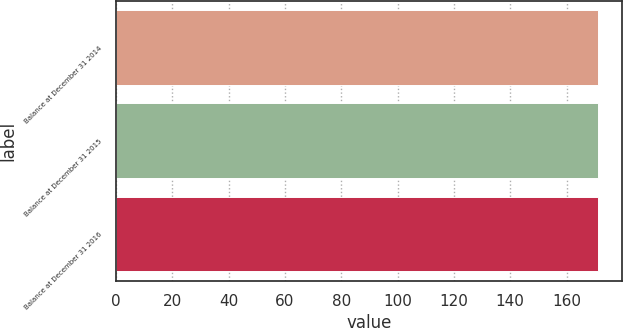<chart> <loc_0><loc_0><loc_500><loc_500><bar_chart><fcel>Balance at December 31 2014<fcel>Balance at December 31 2015<fcel>Balance at December 31 2016<nl><fcel>171<fcel>171.1<fcel>171.2<nl></chart> 